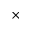Convert formula to latex. <formula><loc_0><loc_0><loc_500><loc_500>\times</formula> 